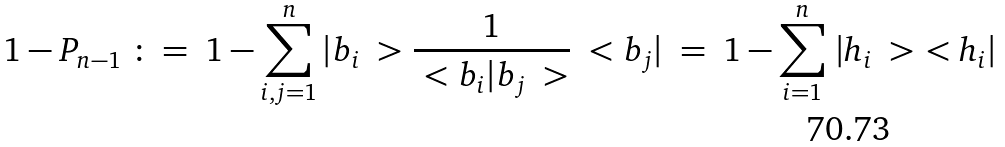Convert formula to latex. <formula><loc_0><loc_0><loc_500><loc_500>1 - P _ { n - 1 } \ \colon = \ 1 - \sum _ { i , j = 1 } ^ { n } | b _ { i } \ > \frac { 1 } { \ < b _ { i } | b _ { j } \ > } \ < b _ { j } | \ = \ 1 - \sum _ { i = 1 } ^ { n } \, | h _ { i } \ > \ < h _ { i } |</formula> 